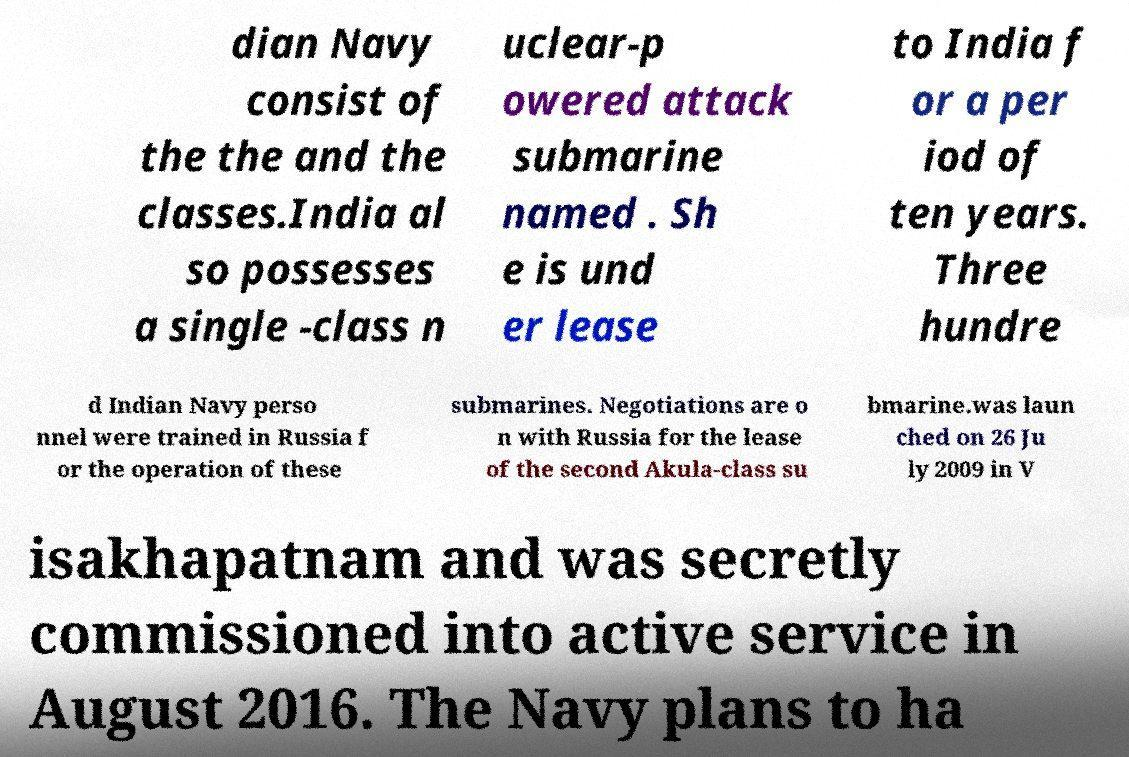Please identify and transcribe the text found in this image. dian Navy consist of the the and the classes.India al so possesses a single -class n uclear-p owered attack submarine named . Sh e is und er lease to India f or a per iod of ten years. Three hundre d Indian Navy perso nnel were trained in Russia f or the operation of these submarines. Negotiations are o n with Russia for the lease of the second Akula-class su bmarine.was laun ched on 26 Ju ly 2009 in V isakhapatnam and was secretly commissioned into active service in August 2016. The Navy plans to ha 